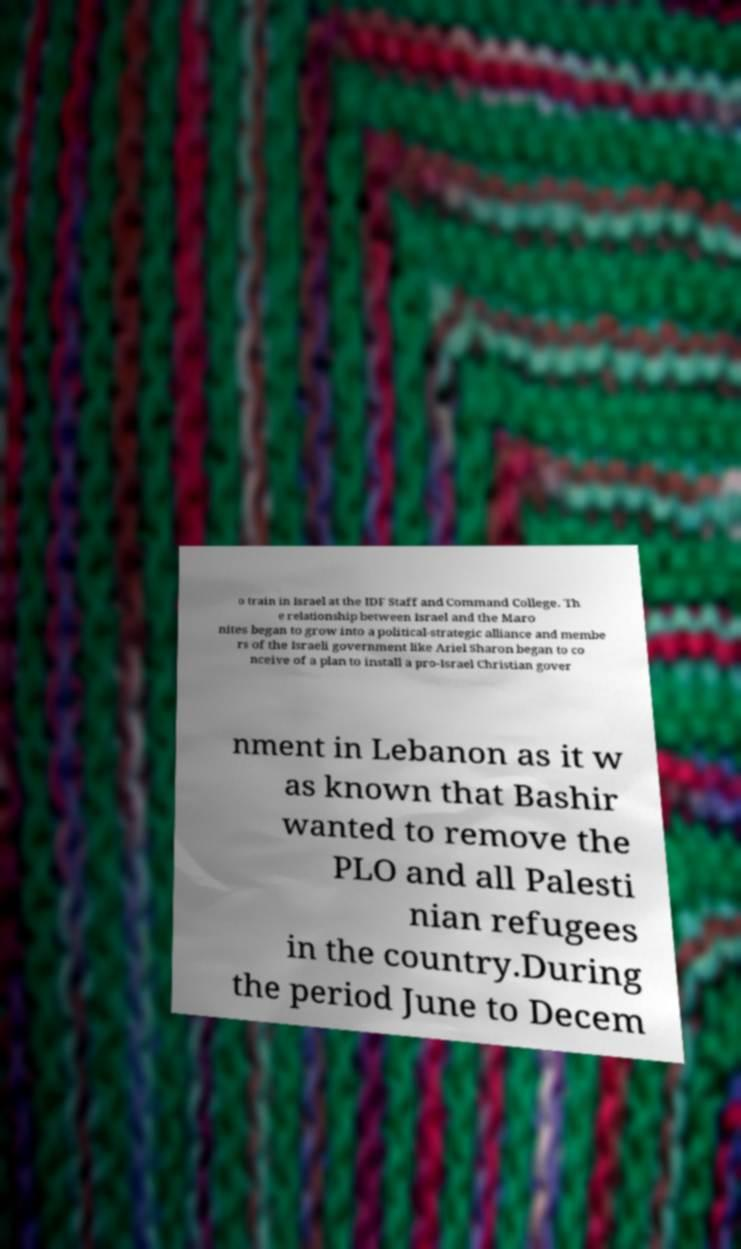There's text embedded in this image that I need extracted. Can you transcribe it verbatim? o train in Israel at the IDF Staff and Command College. Th e relationship between Israel and the Maro nites began to grow into a political-strategic alliance and membe rs of the Israeli government like Ariel Sharon began to co nceive of a plan to install a pro-Israel Christian gover nment in Lebanon as it w as known that Bashir wanted to remove the PLO and all Palesti nian refugees in the country.During the period June to Decem 